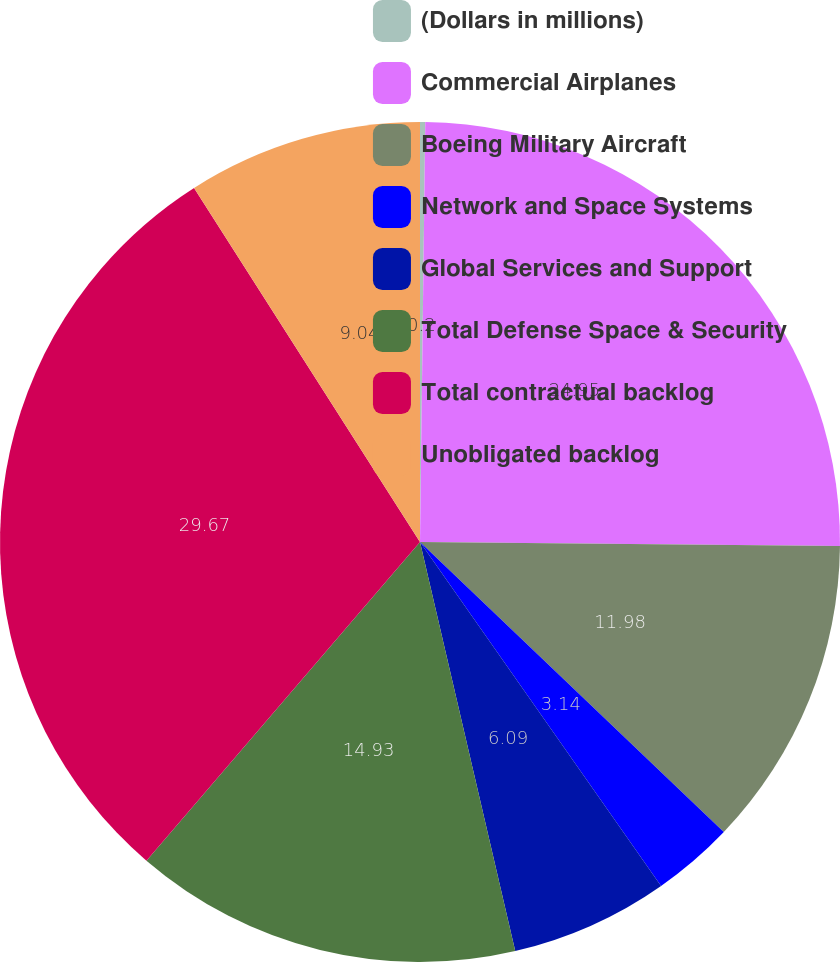<chart> <loc_0><loc_0><loc_500><loc_500><pie_chart><fcel>(Dollars in millions)<fcel>Commercial Airplanes<fcel>Boeing Military Aircraft<fcel>Network and Space Systems<fcel>Global Services and Support<fcel>Total Defense Space & Security<fcel>Total contractual backlog<fcel>Unobligated backlog<nl><fcel>0.2%<fcel>24.95%<fcel>11.98%<fcel>3.14%<fcel>6.09%<fcel>14.93%<fcel>29.67%<fcel>9.04%<nl></chart> 